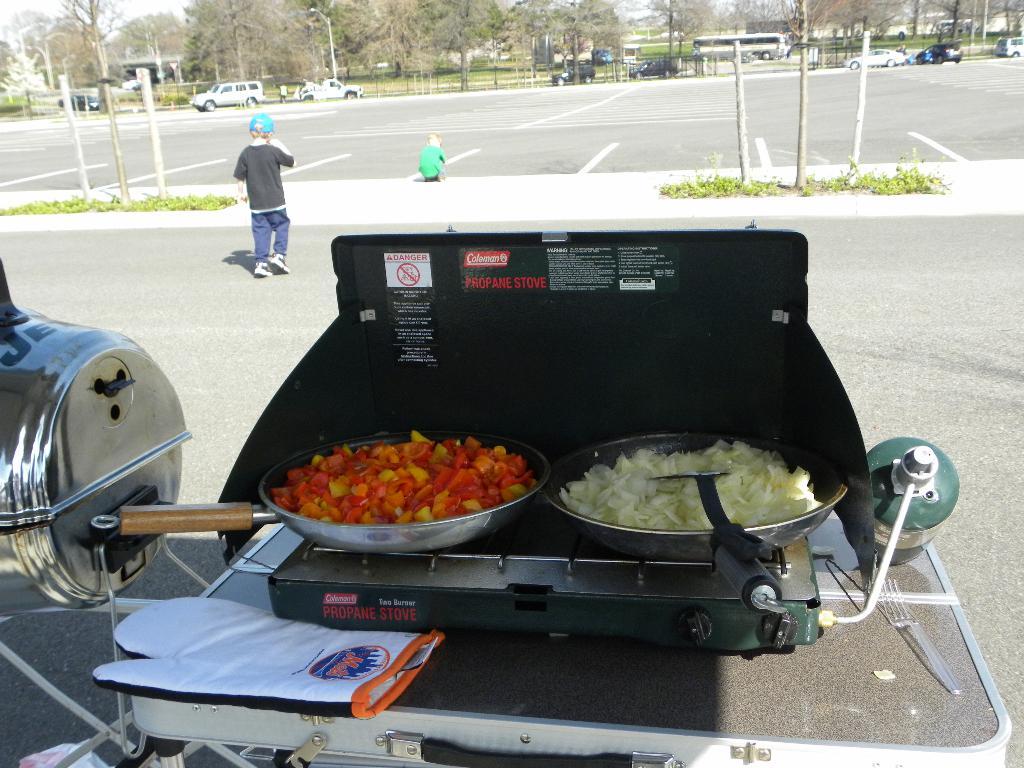What is the brand of the stove?
Provide a short and direct response. Coleman. 